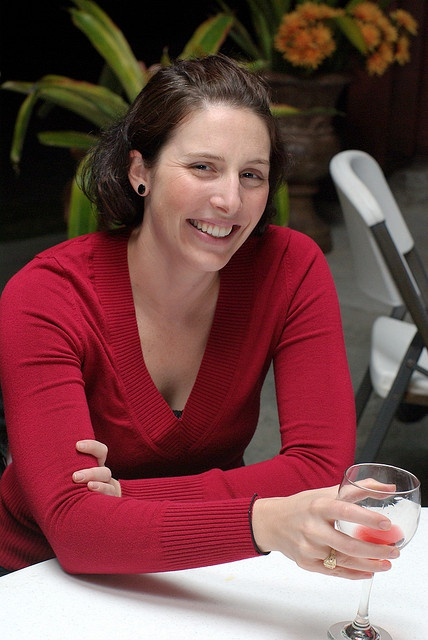Describe the objects in this image and their specific colors. I can see people in black, brown, and maroon tones, dining table in black, white, darkgray, brown, and maroon tones, potted plant in black, maroon, olive, and brown tones, chair in black, darkgray, gray, and lightgray tones, and potted plant in black and darkgreen tones in this image. 